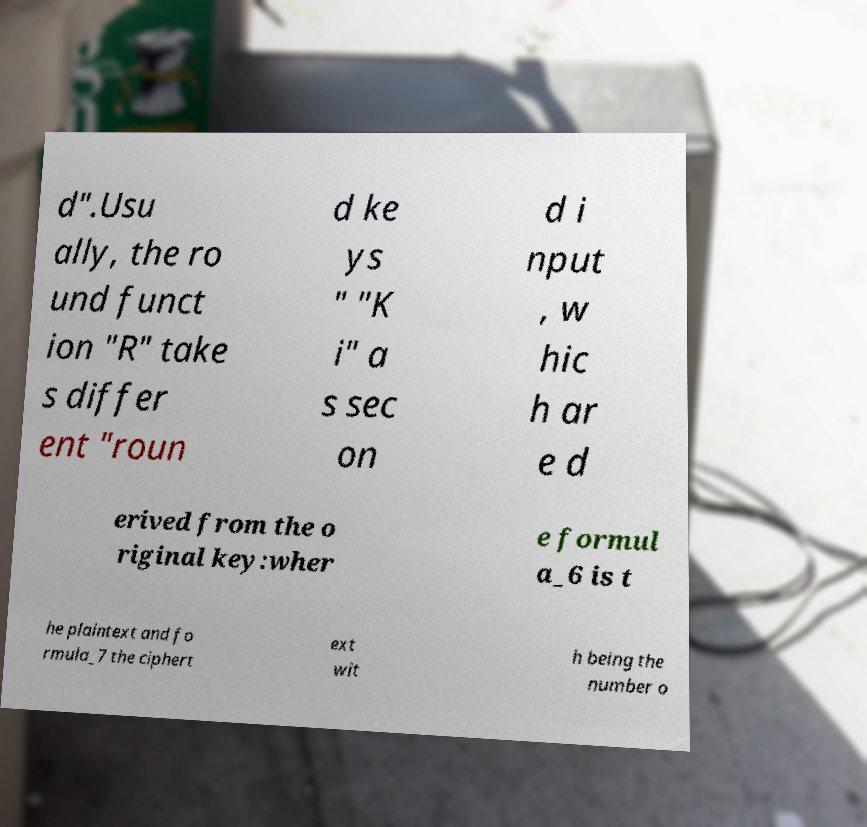Can you read and provide the text displayed in the image?This photo seems to have some interesting text. Can you extract and type it out for me? d".Usu ally, the ro und funct ion "R" take s differ ent "roun d ke ys " "K i" a s sec on d i nput , w hic h ar e d erived from the o riginal key:wher e formul a_6 is t he plaintext and fo rmula_7 the ciphert ext wit h being the number o 